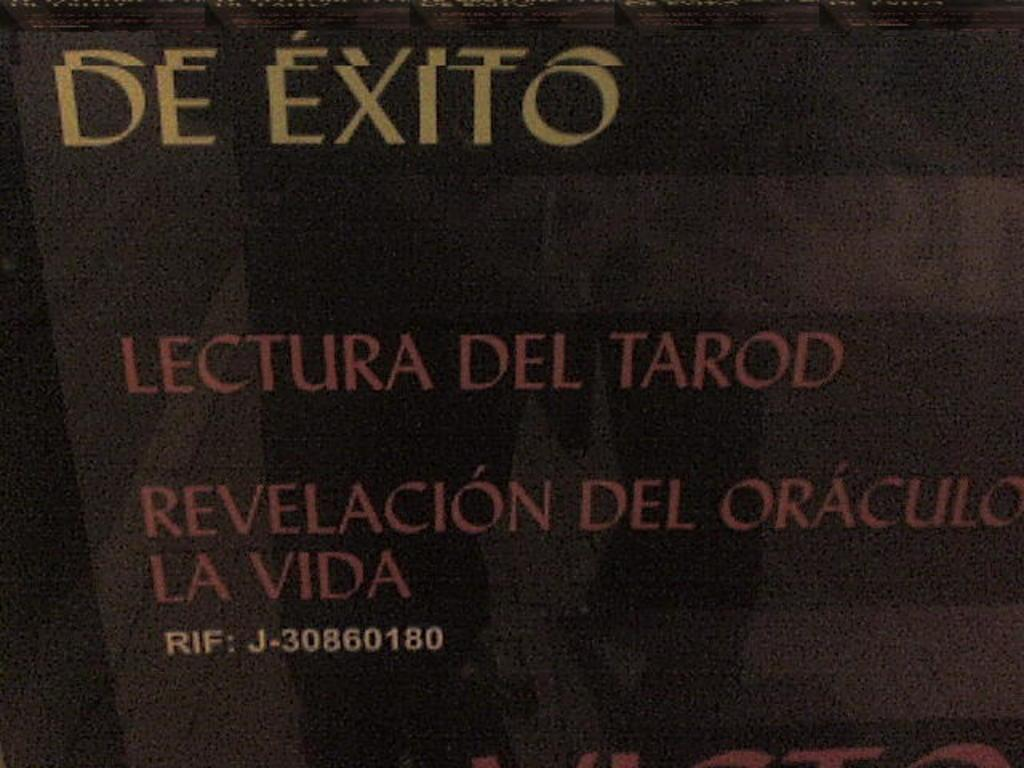<image>
Relay a brief, clear account of the picture shown. The title De Exito in gold print is above the words Lectura Del Tarod in red print on a black background. 